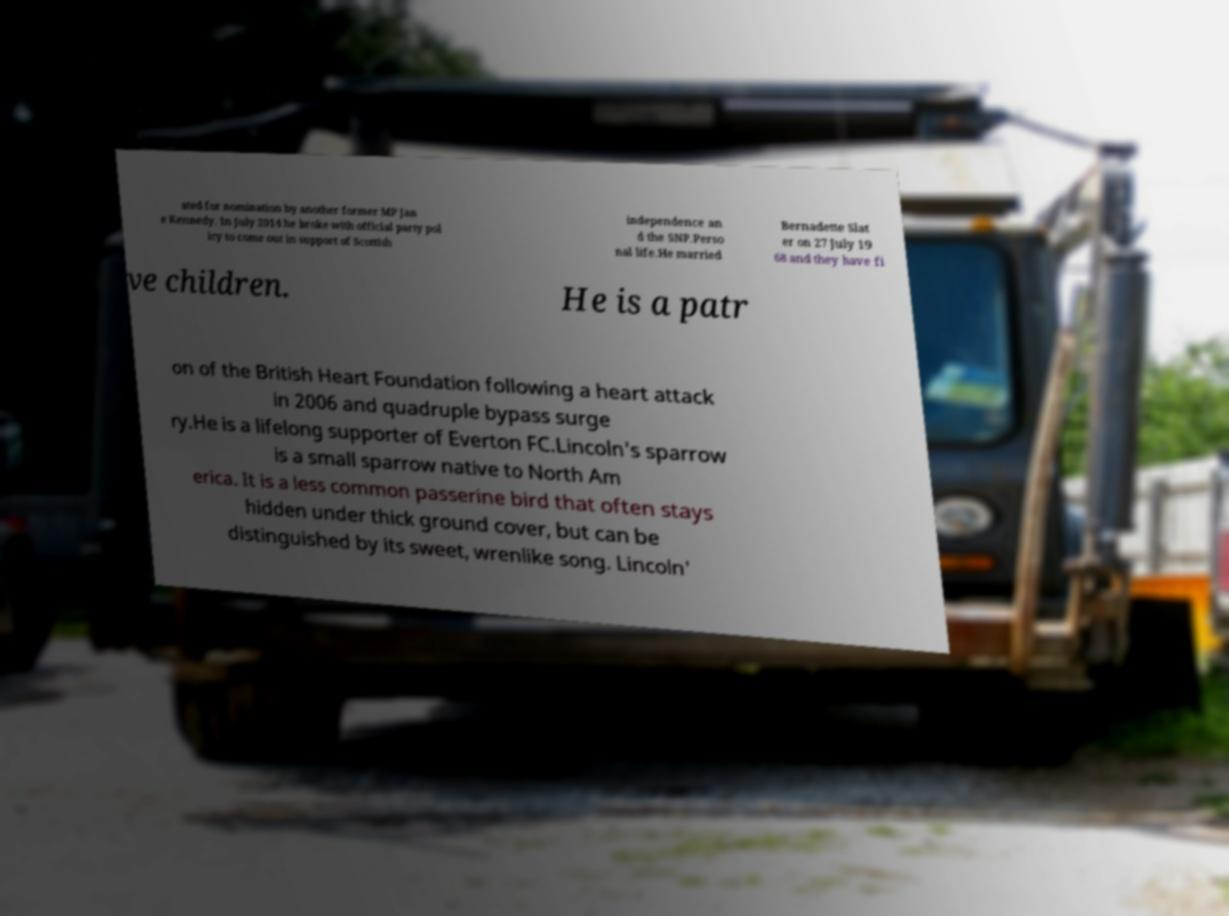What messages or text are displayed in this image? I need them in a readable, typed format. ated for nomination by another former MP Jan e Kennedy. In July 2014 he broke with official party pol icy to come out in support of Scottish independence an d the SNP.Perso nal life.He married Bernadette Slat er on 27 July 19 68 and they have fi ve children. He is a patr on of the British Heart Foundation following a heart attack in 2006 and quadruple bypass surge ry.He is a lifelong supporter of Everton FC.Lincoln's sparrow is a small sparrow native to North Am erica. It is a less common passerine bird that often stays hidden under thick ground cover, but can be distinguished by its sweet, wrenlike song. Lincoln' 